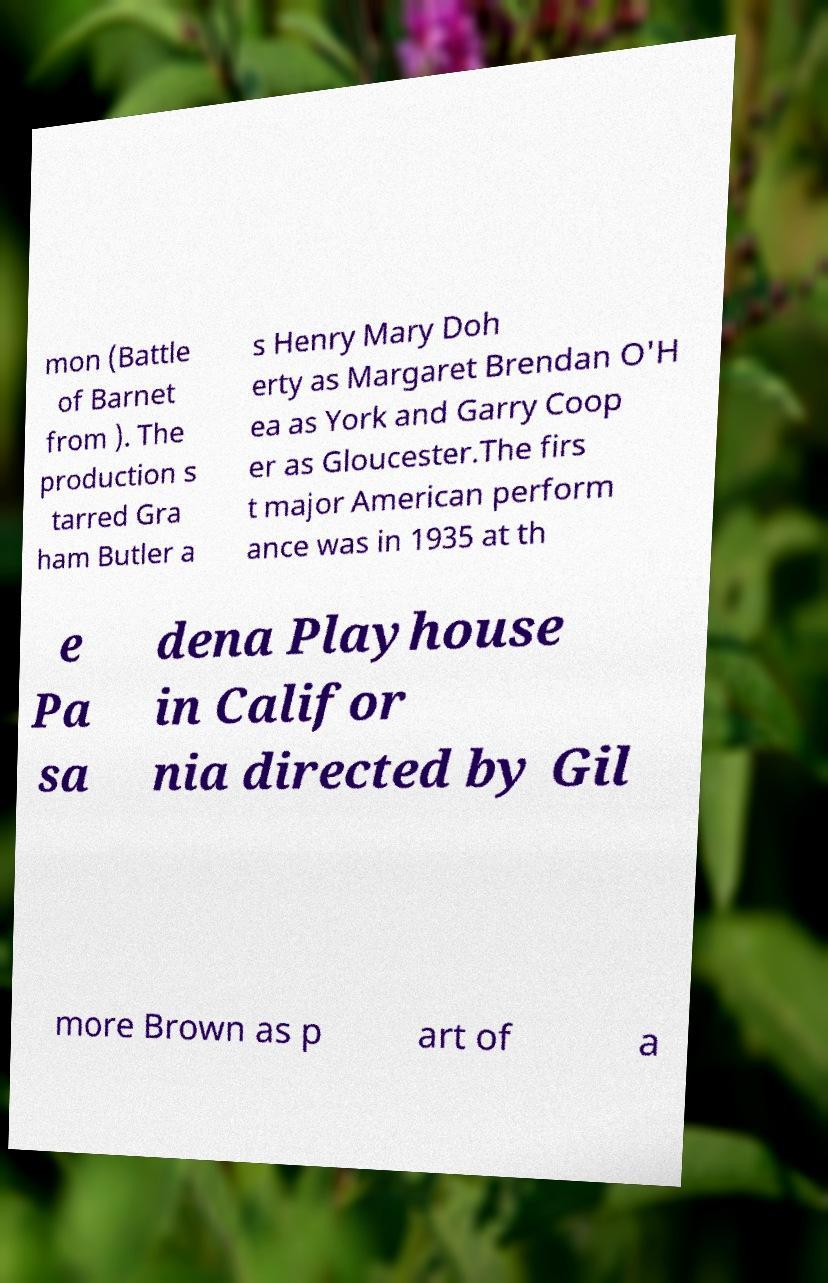Can you accurately transcribe the text from the provided image for me? mon (Battle of Barnet from ). The production s tarred Gra ham Butler a s Henry Mary Doh erty as Margaret Brendan O'H ea as York and Garry Coop er as Gloucester.The firs t major American perform ance was in 1935 at th e Pa sa dena Playhouse in Califor nia directed by Gil more Brown as p art of a 